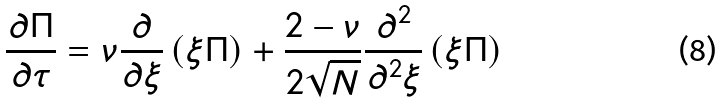<formula> <loc_0><loc_0><loc_500><loc_500>\frac { \partial \Pi } { \partial \tau } = \nu \frac { \partial } { \partial \xi } \left ( \xi \Pi \right ) + \frac { 2 - \nu } { 2 \sqrt { N } } \frac { \partial ^ { 2 } } { \partial ^ { 2 } \xi } \left ( \xi \Pi \right )</formula> 